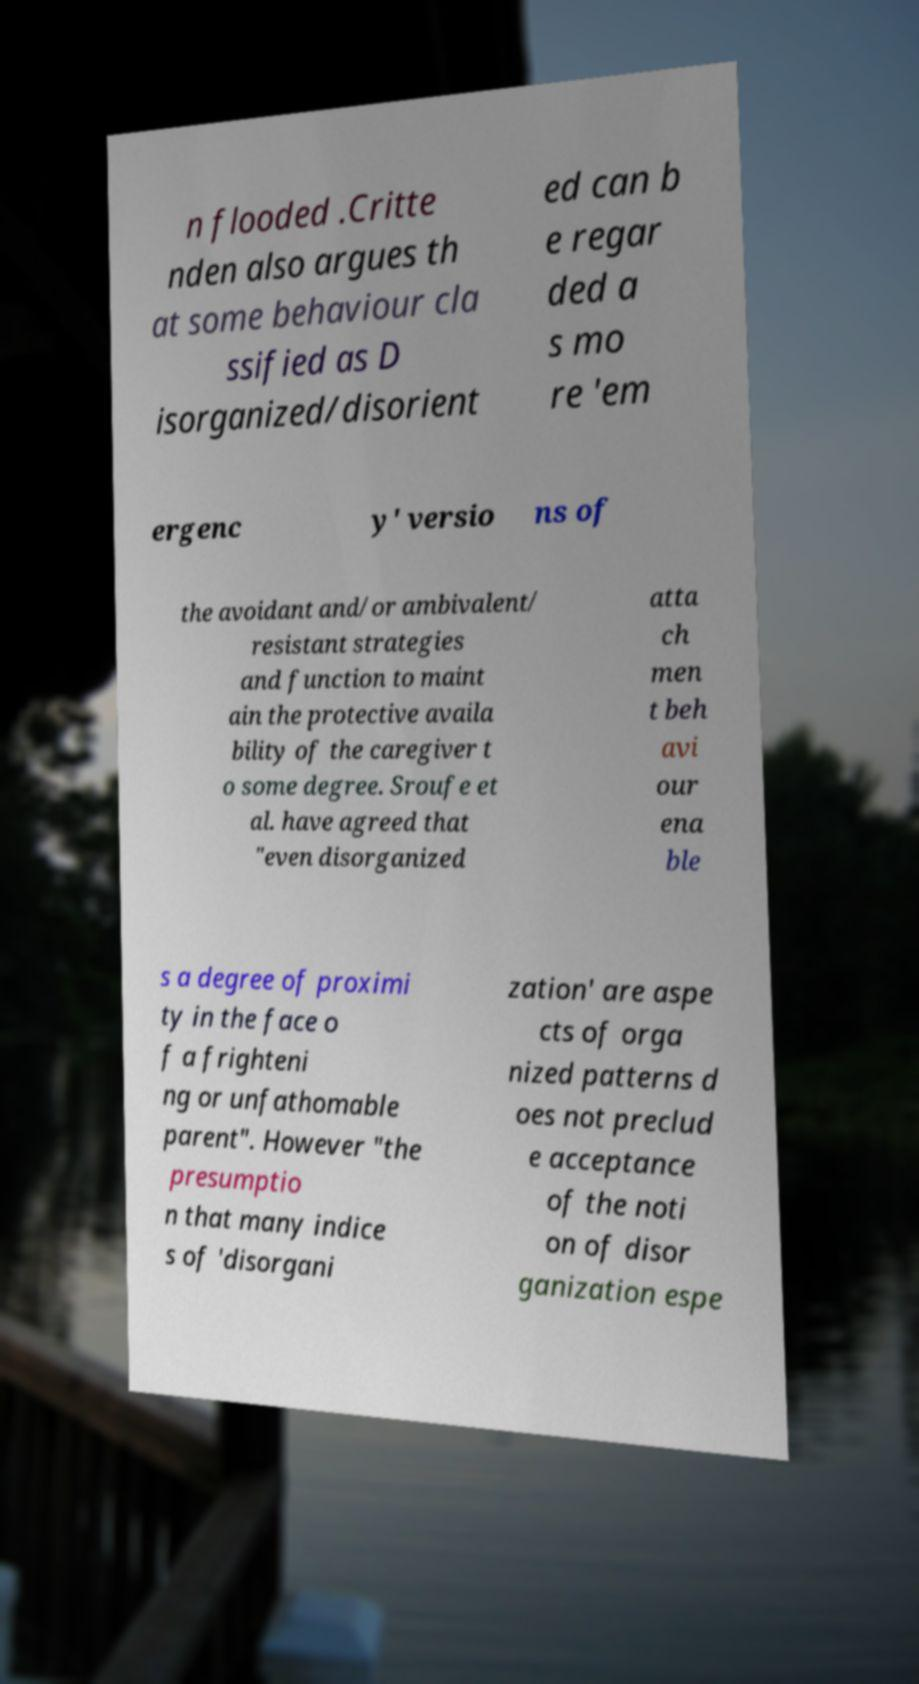Can you accurately transcribe the text from the provided image for me? n flooded .Critte nden also argues th at some behaviour cla ssified as D isorganized/disorient ed can b e regar ded a s mo re 'em ergenc y' versio ns of the avoidant and/or ambivalent/ resistant strategies and function to maint ain the protective availa bility of the caregiver t o some degree. Sroufe et al. have agreed that "even disorganized atta ch men t beh avi our ena ble s a degree of proximi ty in the face o f a frighteni ng or unfathomable parent". However "the presumptio n that many indice s of 'disorgani zation' are aspe cts of orga nized patterns d oes not preclud e acceptance of the noti on of disor ganization espe 